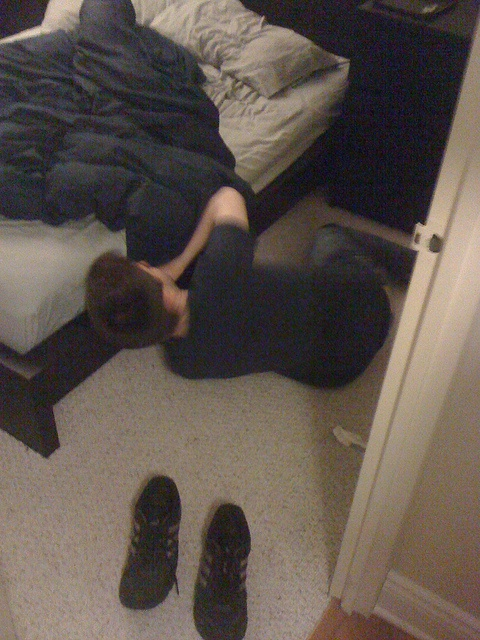Describe the objects in this image and their specific colors. I can see bed in purple, black, gray, and darkgray tones and people in purple, black, and gray tones in this image. 